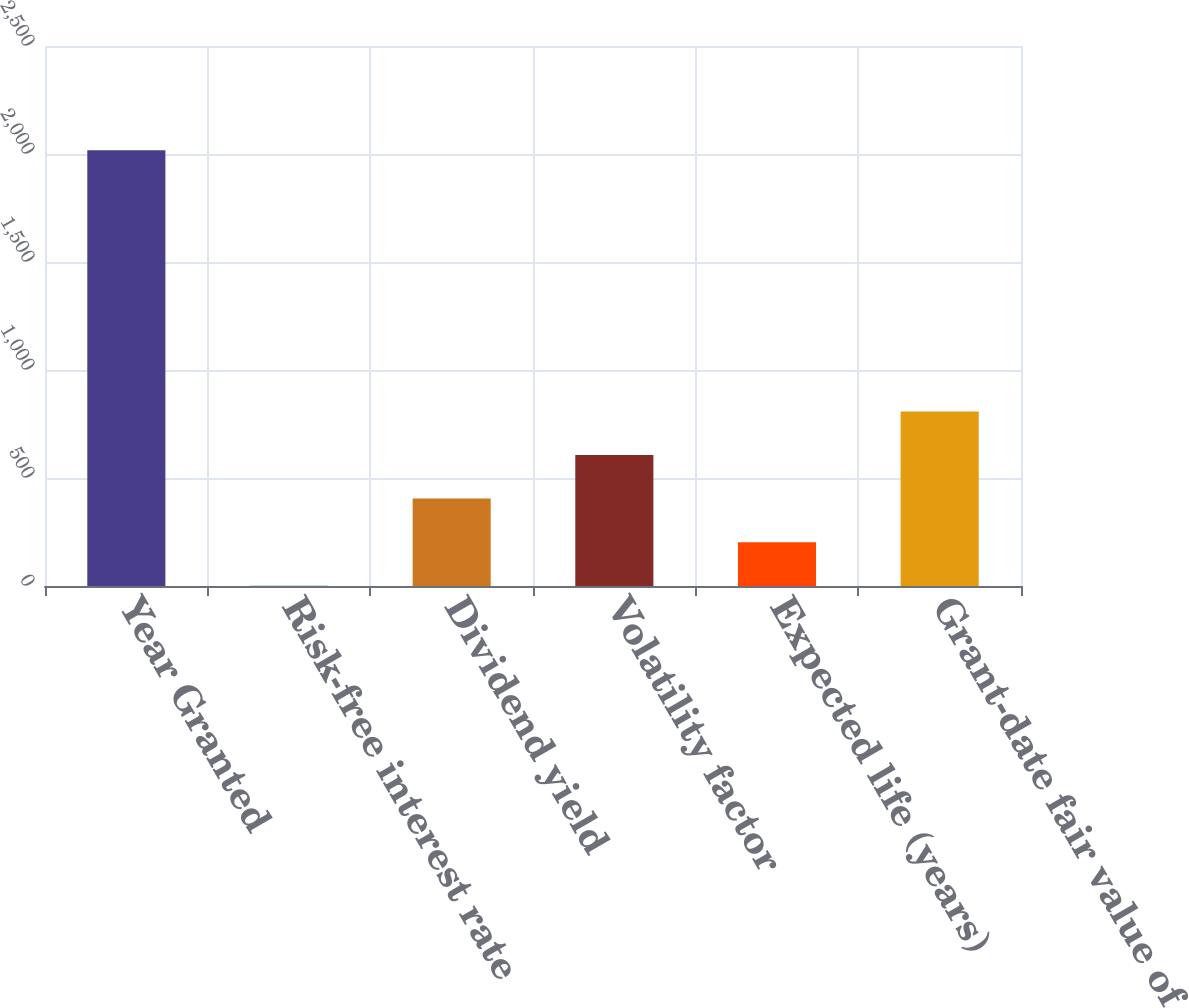Convert chart to OTSL. <chart><loc_0><loc_0><loc_500><loc_500><bar_chart><fcel>Year Granted<fcel>Risk-free interest rate<fcel>Dividend yield<fcel>Volatility factor<fcel>Expected life (years)<fcel>Grant-date fair value of<nl><fcel>2017<fcel>1.5<fcel>404.6<fcel>606.15<fcel>203.05<fcel>807.7<nl></chart> 